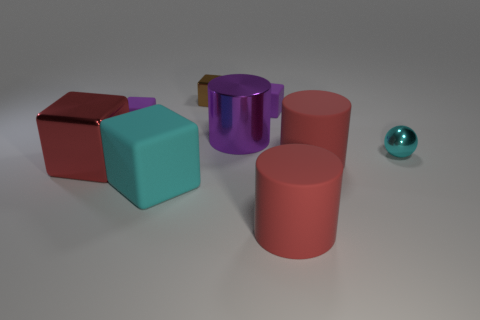Subtract all red cylinders. How many cylinders are left? 1 Subtract 0 yellow balls. How many objects are left? 9 Subtract all spheres. How many objects are left? 8 Subtract 1 balls. How many balls are left? 0 Subtract all gray spheres. Subtract all blue cylinders. How many spheres are left? 1 Subtract all green blocks. How many purple spheres are left? 0 Subtract all large shiny cubes. Subtract all big cylinders. How many objects are left? 5 Add 6 big purple metal cylinders. How many big purple metal cylinders are left? 7 Add 4 red shiny blocks. How many red shiny blocks exist? 5 Add 1 purple cylinders. How many objects exist? 10 